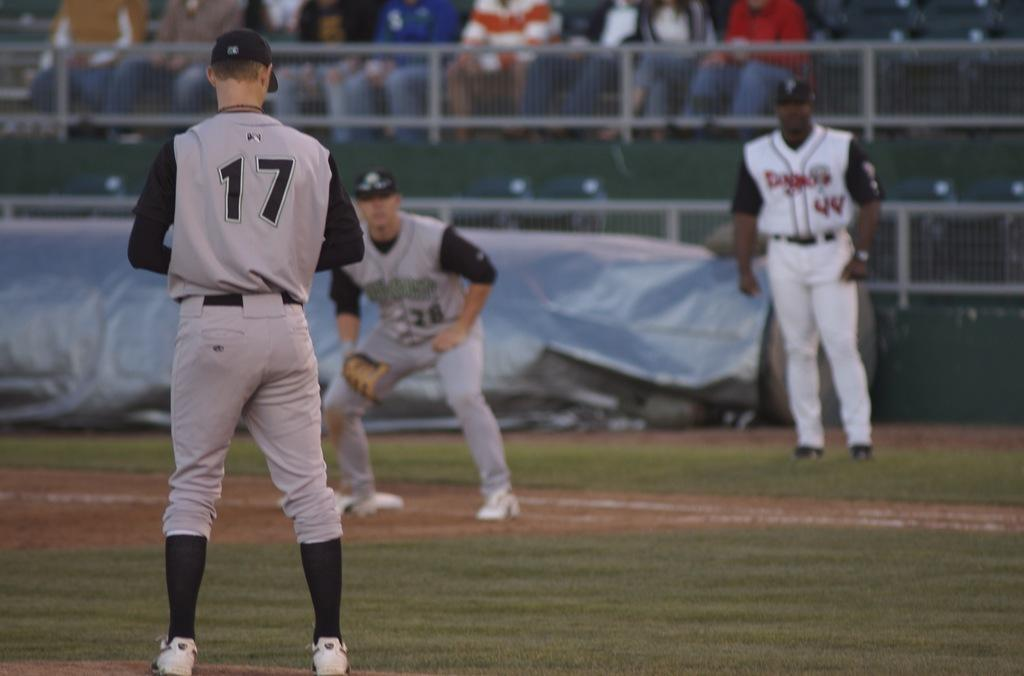<image>
Give a short and clear explanation of the subsequent image. A baseball player with the number 17 on his shirt is about to pitch. 